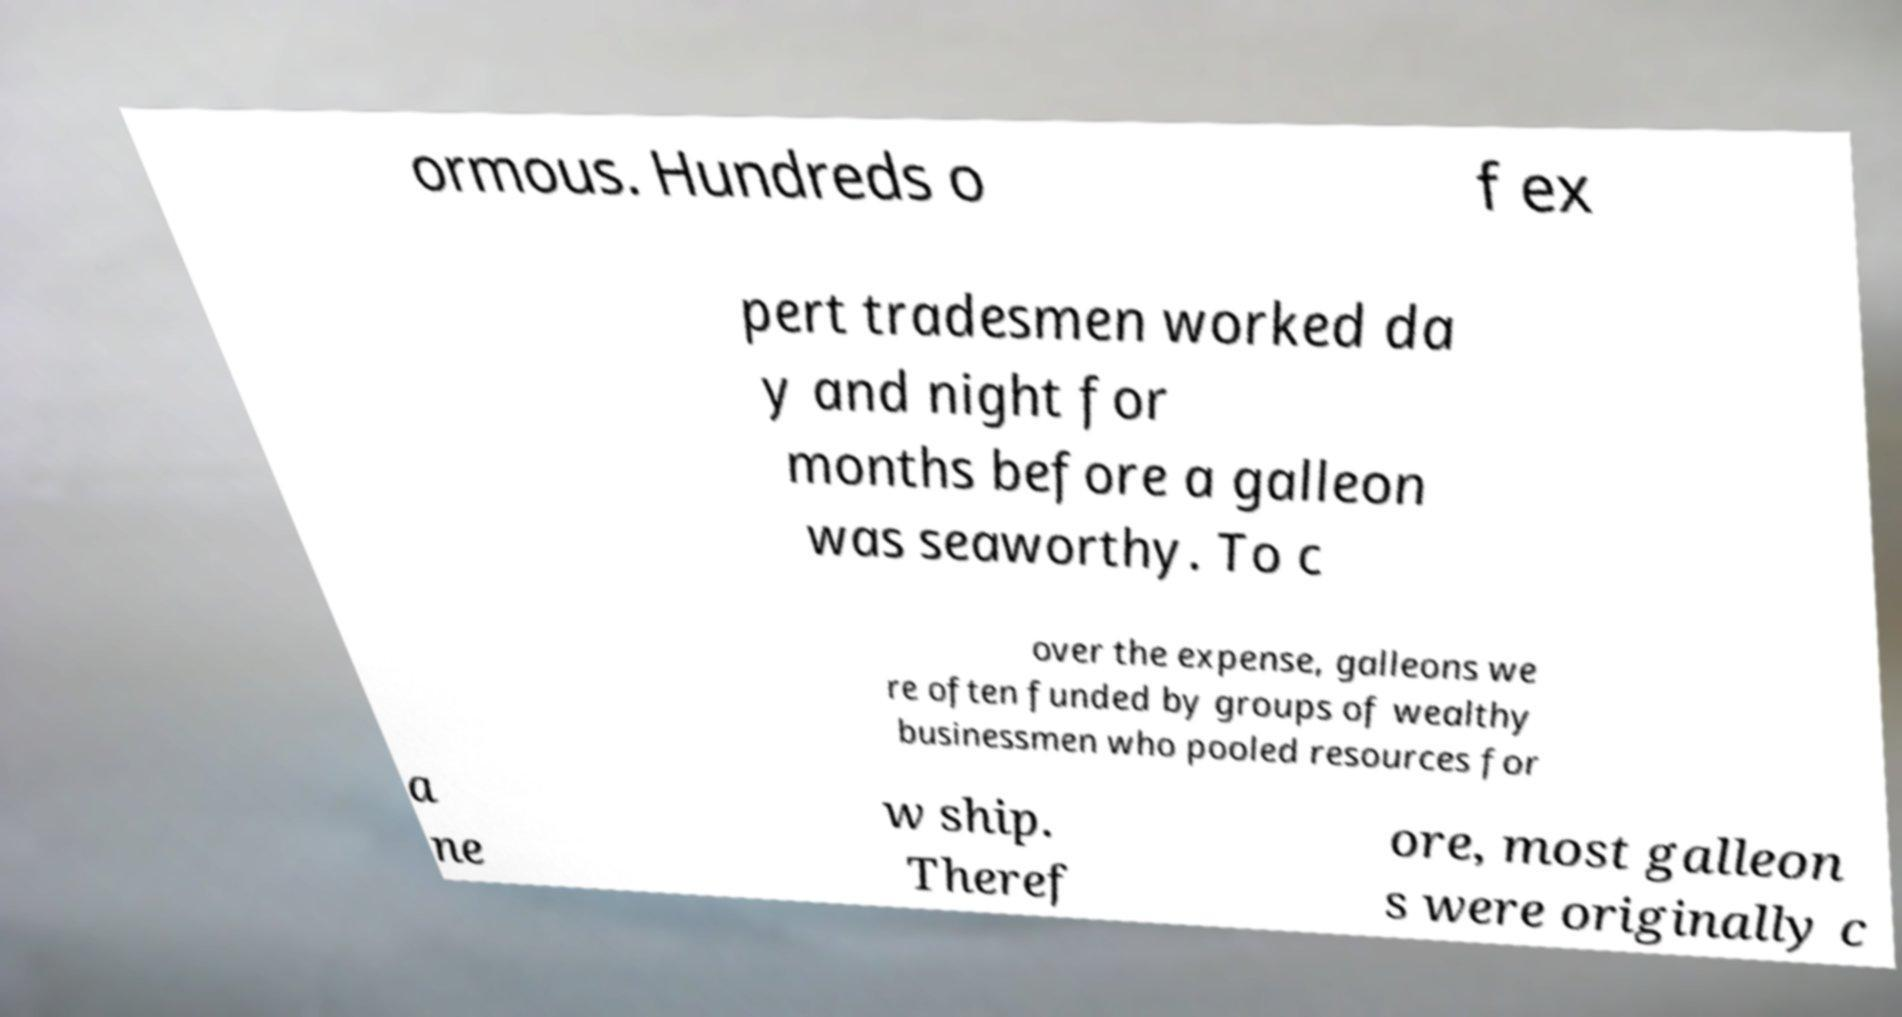Can you read and provide the text displayed in the image?This photo seems to have some interesting text. Can you extract and type it out for me? ormous. Hundreds o f ex pert tradesmen worked da y and night for months before a galleon was seaworthy. To c over the expense, galleons we re often funded by groups of wealthy businessmen who pooled resources for a ne w ship. Theref ore, most galleon s were originally c 